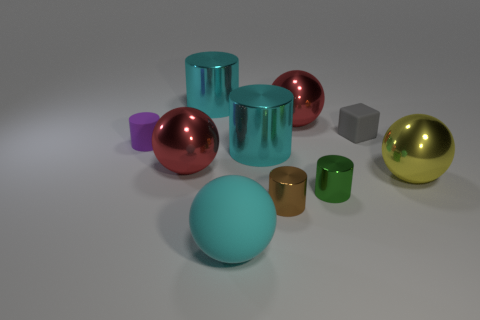Subtract all purple cylinders. How many cylinders are left? 4 Subtract all tiny matte cylinders. How many cylinders are left? 4 Subtract all gray cylinders. Subtract all brown blocks. How many cylinders are left? 5 Subtract all balls. How many objects are left? 6 Add 1 cubes. How many cubes exist? 2 Subtract 0 yellow cylinders. How many objects are left? 10 Subtract all green shiny spheres. Subtract all big yellow balls. How many objects are left? 9 Add 2 brown shiny objects. How many brown shiny objects are left? 3 